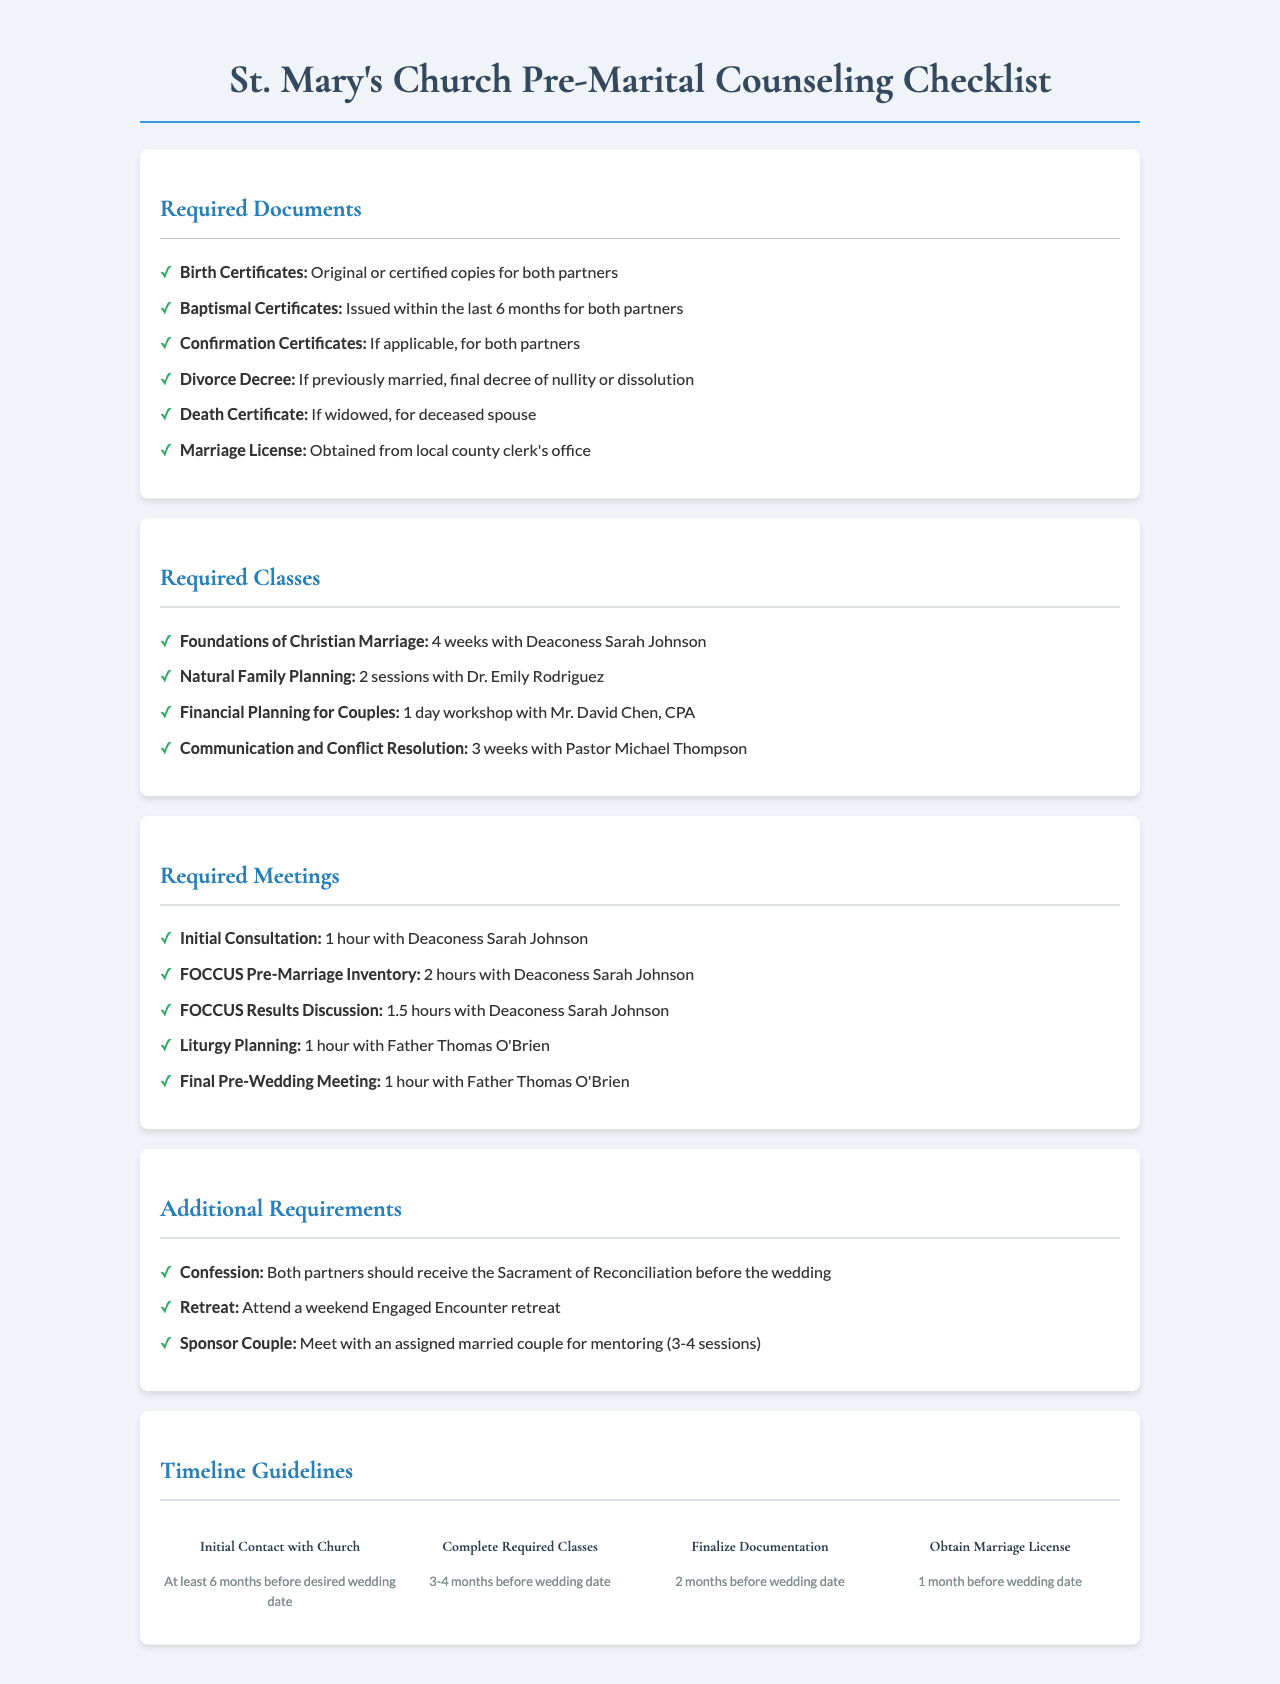What is the title of the document? The title of the document is stated at the top, indicating the purpose of the checklist.
Answer: St. Mary's Church Pre-Marital Counseling Checklist How many required documents are listed? The number of required documents can be counted in the document section that outlines these items.
Answer: 6 Who is the instructor for the "Foundations of Christian Marriage" class? The instructor's name for each required class is provided in the class section.
Answer: Deaconess Sarah Johnson What is the duration of the "Natural Family Planning" class? The duration for each class is indicated next to the class name.
Answer: 2 sessions When should the initial contact with the church be made? This timeline guideline is specified in the document for the first milestone.
Answer: At least 6 months before desired wedding date Which document is required if one partner is widowed? The document section specifies what is needed in such a situation, which relates specifically to marital status.
Answer: Death Certificate How long is the "FOCCUS Pre-Marriage Inventory" meeting? The duration for each required meeting is listed in the meetings section.
Answer: 2 hours What is one of the additional requirements before the wedding? The list of additional requirements provides several expectations for the couple prior to the wedding.
Answer: Confession Who conducts the "Liturgy Planning" meeting? The person responsible for this meeting is mentioned in the meeting section of the document.
Answer: Father Thomas O'Brien What is the duration of the "Financial Planning for Couples" workshop? The length of this specific class is provided in the required classes section.
Answer: 1 day workshop 